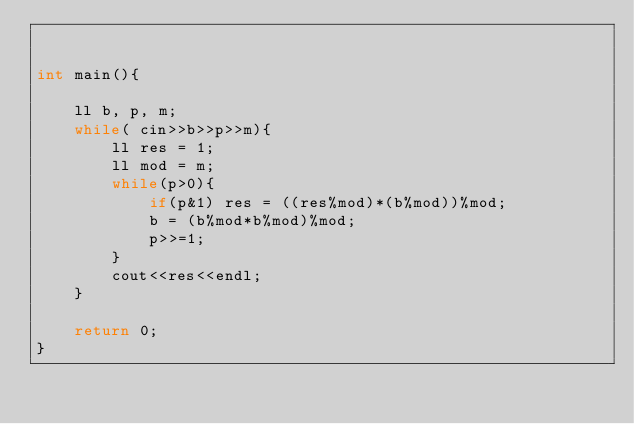<code> <loc_0><loc_0><loc_500><loc_500><_C++_>

int main(){
	
	ll b, p, m;
	while( cin>>b>>p>>m){
		ll res = 1;
		ll mod = m;
		while(p>0){
			if(p&1) res = ((res%mod)*(b%mod))%mod;
			b = (b%mod*b%mod)%mod;
			p>>=1;
		}
		cout<<res<<endl;
	} 
	
	return 0;
}

</code> 